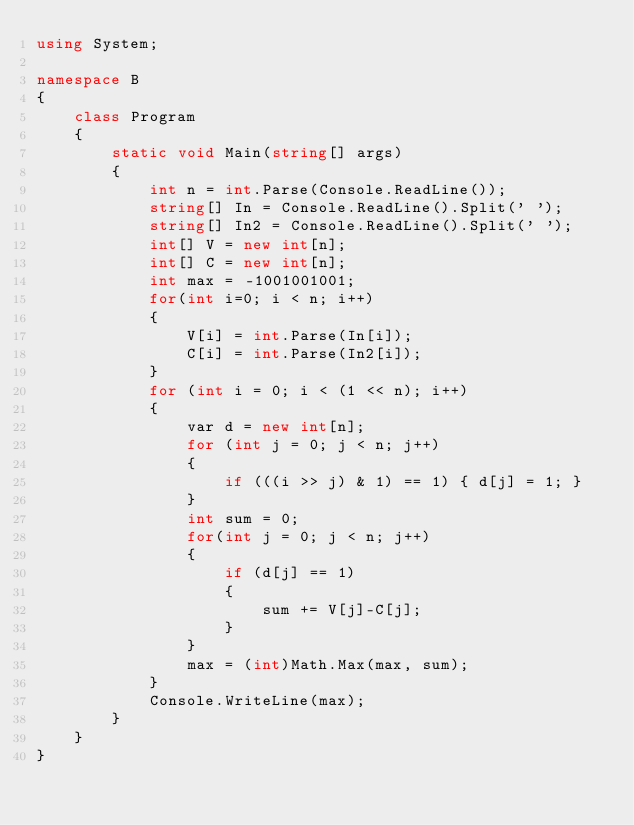<code> <loc_0><loc_0><loc_500><loc_500><_C#_>using System;

namespace B
{
    class Program
    {
        static void Main(string[] args)
        {
            int n = int.Parse(Console.ReadLine());
            string[] In = Console.ReadLine().Split(' ');
            string[] In2 = Console.ReadLine().Split(' ');
            int[] V = new int[n];
            int[] C = new int[n];
            int max = -1001001001;
            for(int i=0; i < n; i++)
            {
                V[i] = int.Parse(In[i]);
                C[i] = int.Parse(In2[i]);
            }
            for (int i = 0; i < (1 << n); i++)
            {
                var d = new int[n];
                for (int j = 0; j < n; j++)
                {
                    if (((i >> j) & 1) == 1) { d[j] = 1; }
                }
                int sum = 0;
                for(int j = 0; j < n; j++)
                {
                    if (d[j] == 1)
                    {
                        sum += V[j]-C[j];
                    }
                }
                max = (int)Math.Max(max, sum);
            }
            Console.WriteLine(max);
        }
    }
}
</code> 